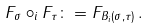<formula> <loc_0><loc_0><loc_500><loc_500>F _ { \sigma } \circ _ { i } F _ { \tau } \colon = F _ { B _ { i } ( \sigma , \tau ) } \, .</formula> 